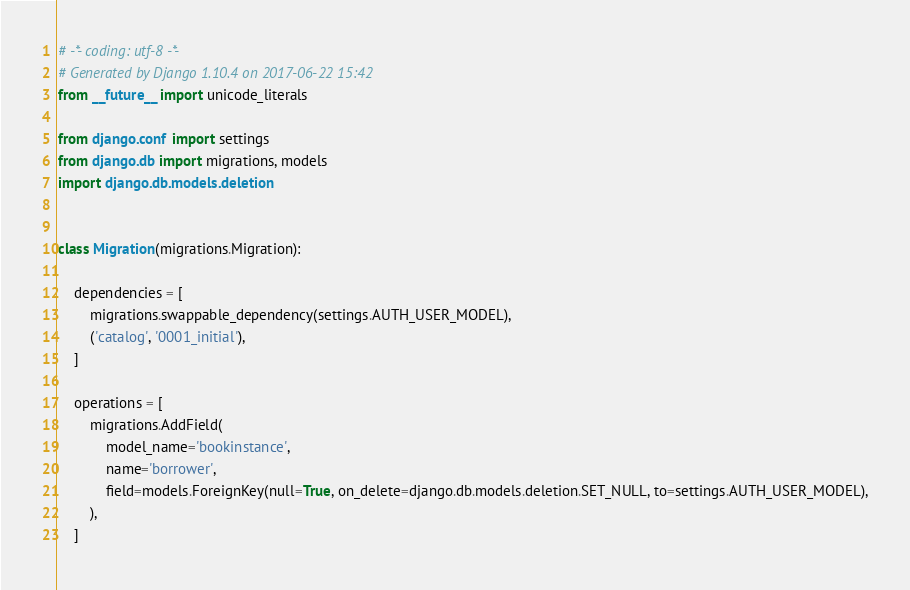Convert code to text. <code><loc_0><loc_0><loc_500><loc_500><_Python_># -*- coding: utf-8 -*-
# Generated by Django 1.10.4 on 2017-06-22 15:42
from __future__ import unicode_literals

from django.conf import settings
from django.db import migrations, models
import django.db.models.deletion


class Migration(migrations.Migration):

    dependencies = [
        migrations.swappable_dependency(settings.AUTH_USER_MODEL),
        ('catalog', '0001_initial'),
    ]

    operations = [
        migrations.AddField(
            model_name='bookinstance',
            name='borrower',
            field=models.ForeignKey(null=True, on_delete=django.db.models.deletion.SET_NULL, to=settings.AUTH_USER_MODEL),
        ),
    ]
</code> 